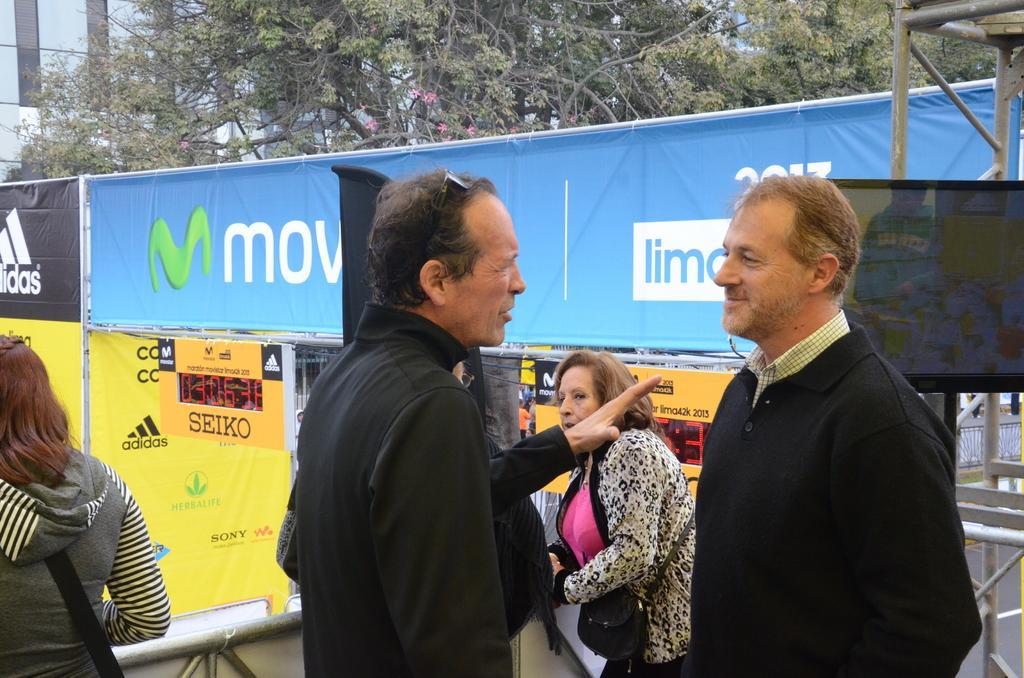Please provide a concise description of this image. In the middle of the image few people are standing. Behind them we can see some tents. At the top of the image we can see some trees. Behind the trees we can see some buildings. 